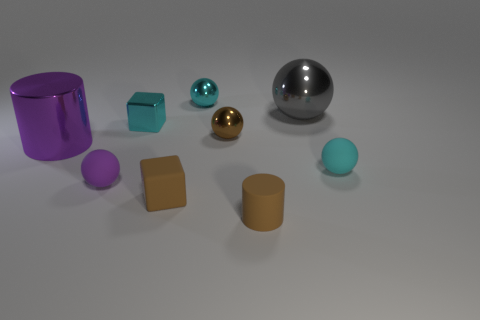There is a cube that is made of the same material as the large purple cylinder; what size is it?
Offer a very short reply. Small. How many brown things are metal objects or metal cubes?
Provide a succinct answer. 1. How many purple balls are in front of the metallic thing that is behind the gray object?
Your response must be concise. 1. Is the number of brown cubes that are to the left of the small purple thing greater than the number of small brown spheres in front of the brown matte cylinder?
Make the answer very short. No. What is the material of the gray ball?
Your response must be concise. Metal. Is there a gray shiny block that has the same size as the matte cylinder?
Keep it short and to the point. No. There is a brown cylinder that is the same size as the brown cube; what is it made of?
Offer a terse response. Rubber. How many blue rubber cylinders are there?
Make the answer very short. 0. There is a matte sphere to the left of the large gray ball; how big is it?
Offer a terse response. Small. Are there the same number of cyan rubber balls left of the large purple shiny cylinder and metal spheres?
Give a very brief answer. No. 